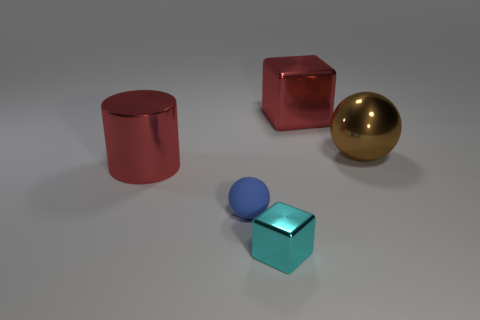Add 3 brown metal spheres. How many objects exist? 8 Subtract all blocks. How many objects are left? 3 Add 5 large red balls. How many large red balls exist? 5 Subtract 0 purple cylinders. How many objects are left? 5 Subtract all big red metallic blocks. Subtract all large red metal blocks. How many objects are left? 3 Add 4 big things. How many big things are left? 7 